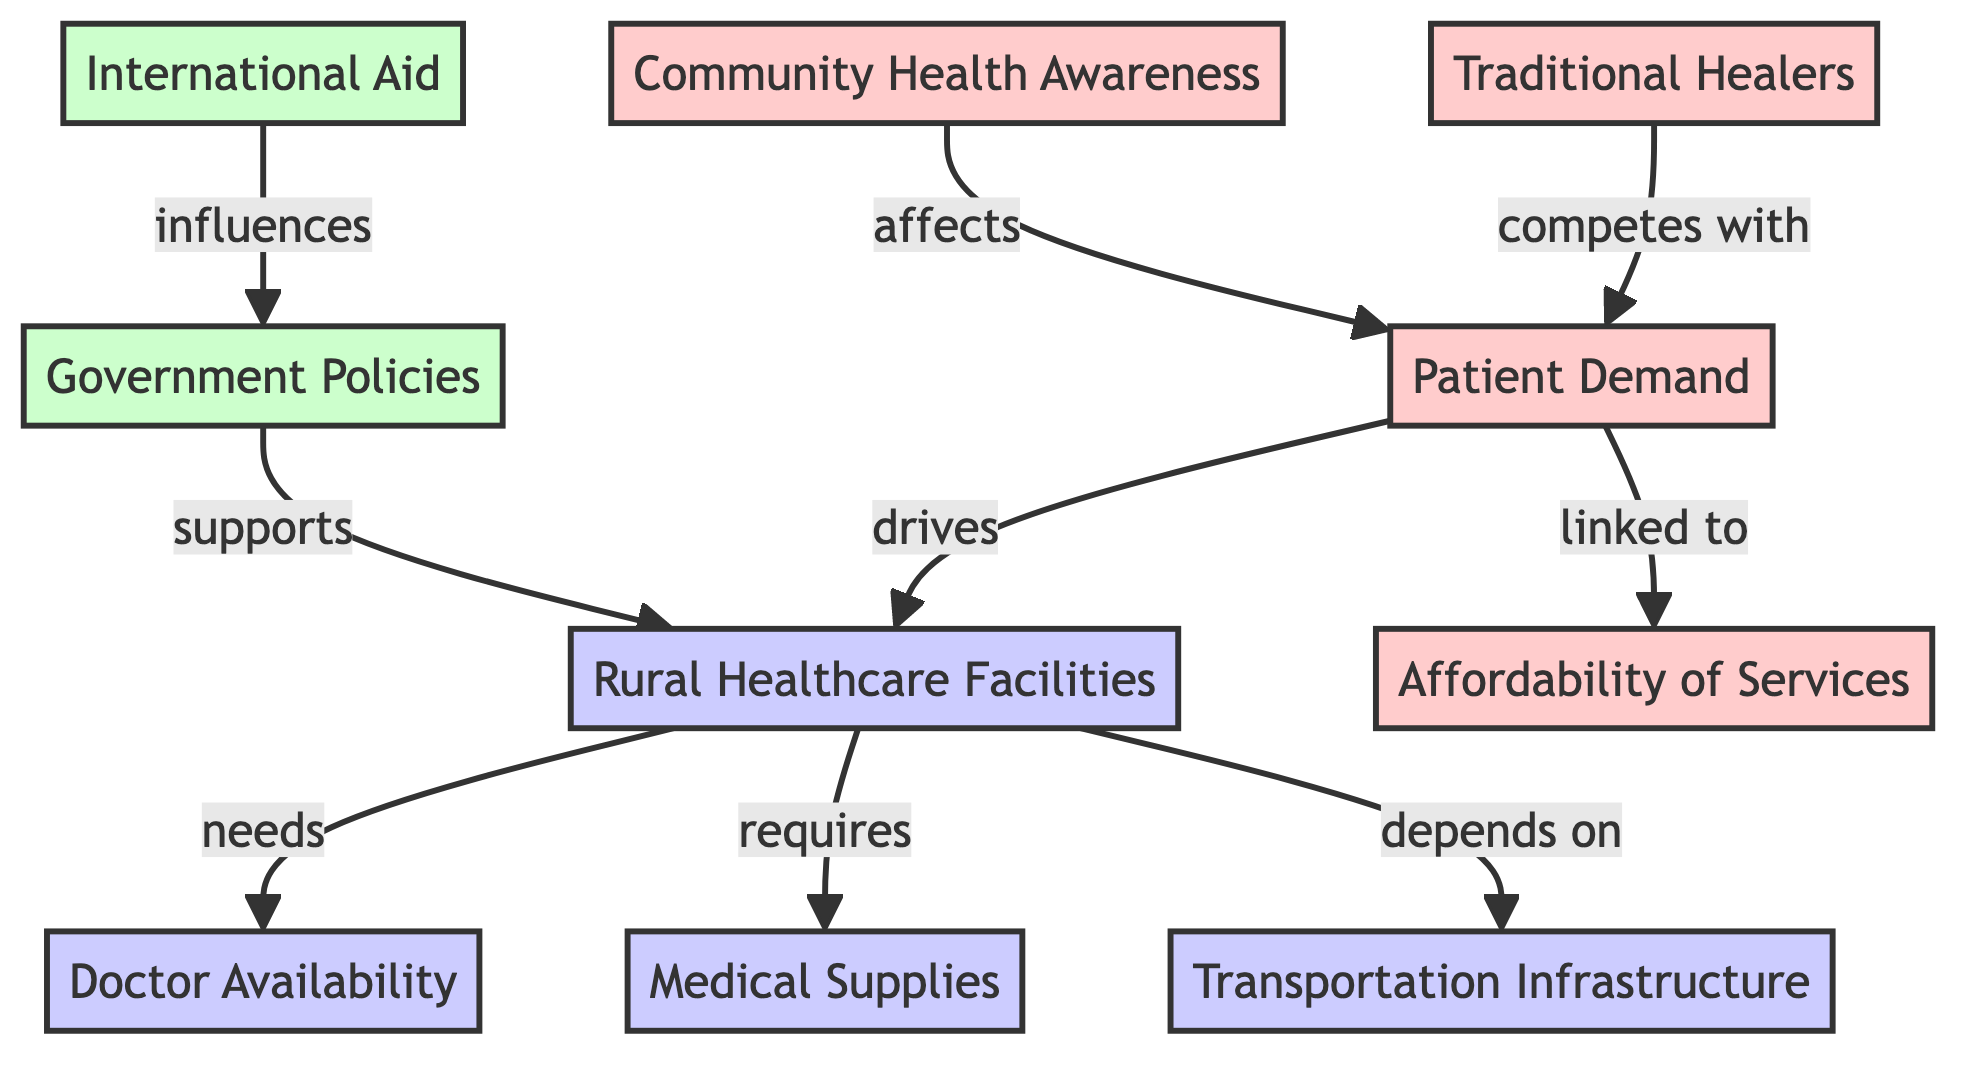What are the three main components of rural healthcare supply? The diagram identifies three main components under rural healthcare facilities: Doctor Availability, Medical Supplies, and Transportation Infrastructure. These are clearly marked as part of the supply nodes.
Answer: Doctor Availability, Medical Supplies, Transportation Infrastructure How many nodes represent demand factors in the diagram? The diagram shows four nodes that represent demand factors: Community Health Awareness, Patient Demand, Affordability of Services, and Traditional Healers. Therefore, the total count of demand nodes is four.
Answer: 4 Which supply factor depends on transportation infrastructure? The arrow originating from Rural Healthcare Facilities points to Transportation Infrastructure, indicating that availability of healthcare facilities depends on transportation infrastructure for access.
Answer: Transportation Infrastructure What does patient demand drive according to the diagram? The arrow from Patient Demand shows that it drives Rural Healthcare Facilities, meaning that increased patient demand leads to a need for more healthcare facilities.
Answer: Rural Healthcare Facilities Which two factors influence government policies? The diagram indicates that International Aid influences Government Policies, and Government Policies supports Rural Healthcare Facilities. Therefore, the two factors are Government Policies and International Aid.
Answer: Government Policies, International Aid How does community health awareness affect patient demand? The diagram illustrates that Community Health Awareness affects Patient Demand; this means that increased awareness leads to changes in the demand for healthcare services.
Answer: Affects Patient Demand 